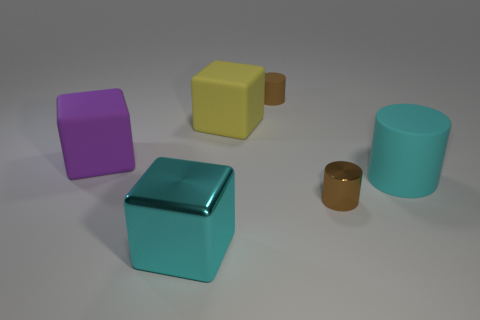There is a big thing that is the same shape as the tiny brown matte thing; what is it made of?
Your response must be concise. Rubber. Is there a cylinder that is behind the brown cylinder that is in front of the thing that is on the right side of the metal cylinder?
Provide a short and direct response. Yes. What is the size of the yellow block that is made of the same material as the large cyan cylinder?
Ensure brevity in your answer.  Large. There is a large cylinder; are there any tiny brown metallic things behind it?
Make the answer very short. No. Is there a cyan cylinder that is on the right side of the cylinder left of the metallic cylinder?
Give a very brief answer. Yes. Do the cylinder in front of the large cyan matte cylinder and the cyan thing that is to the left of the big yellow rubber thing have the same size?
Your answer should be very brief. No. What number of small objects are purple rubber objects or rubber blocks?
Make the answer very short. 0. There is a large cube right of the cyan thing that is to the left of the big yellow matte cube; what is it made of?
Make the answer very short. Rubber. What shape is the object that is the same color as the large metallic cube?
Provide a succinct answer. Cylinder. Are there any large things that have the same material as the large purple block?
Provide a succinct answer. Yes. 